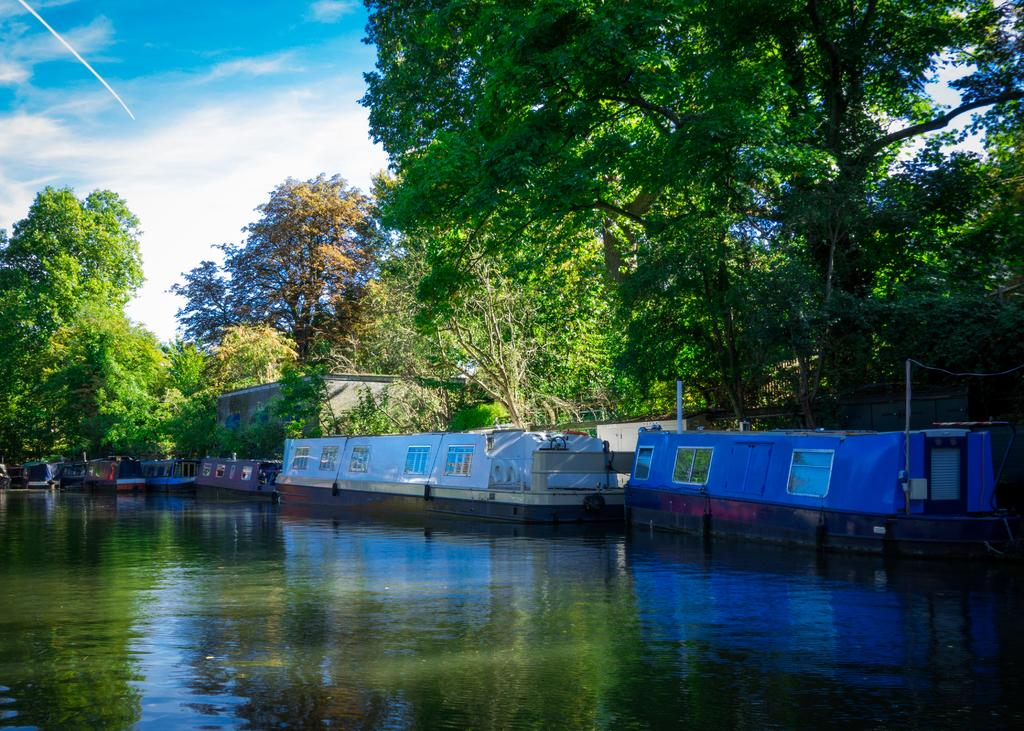What is floating on the water in the image? There are boats floating on the water in the image. What type of vegetation can be seen in the image? There are trees visible in the image. What is visible in the background of the image? The sky is visible in the background of the image. What can be seen in the sky in the image? Clouds are present in the sky. What is the cause of the quartz in the image? There is no quartz present in the image. How many men are visible in the image? There is no mention of men in the provided facts, so we cannot determine their presence or number in the image. 